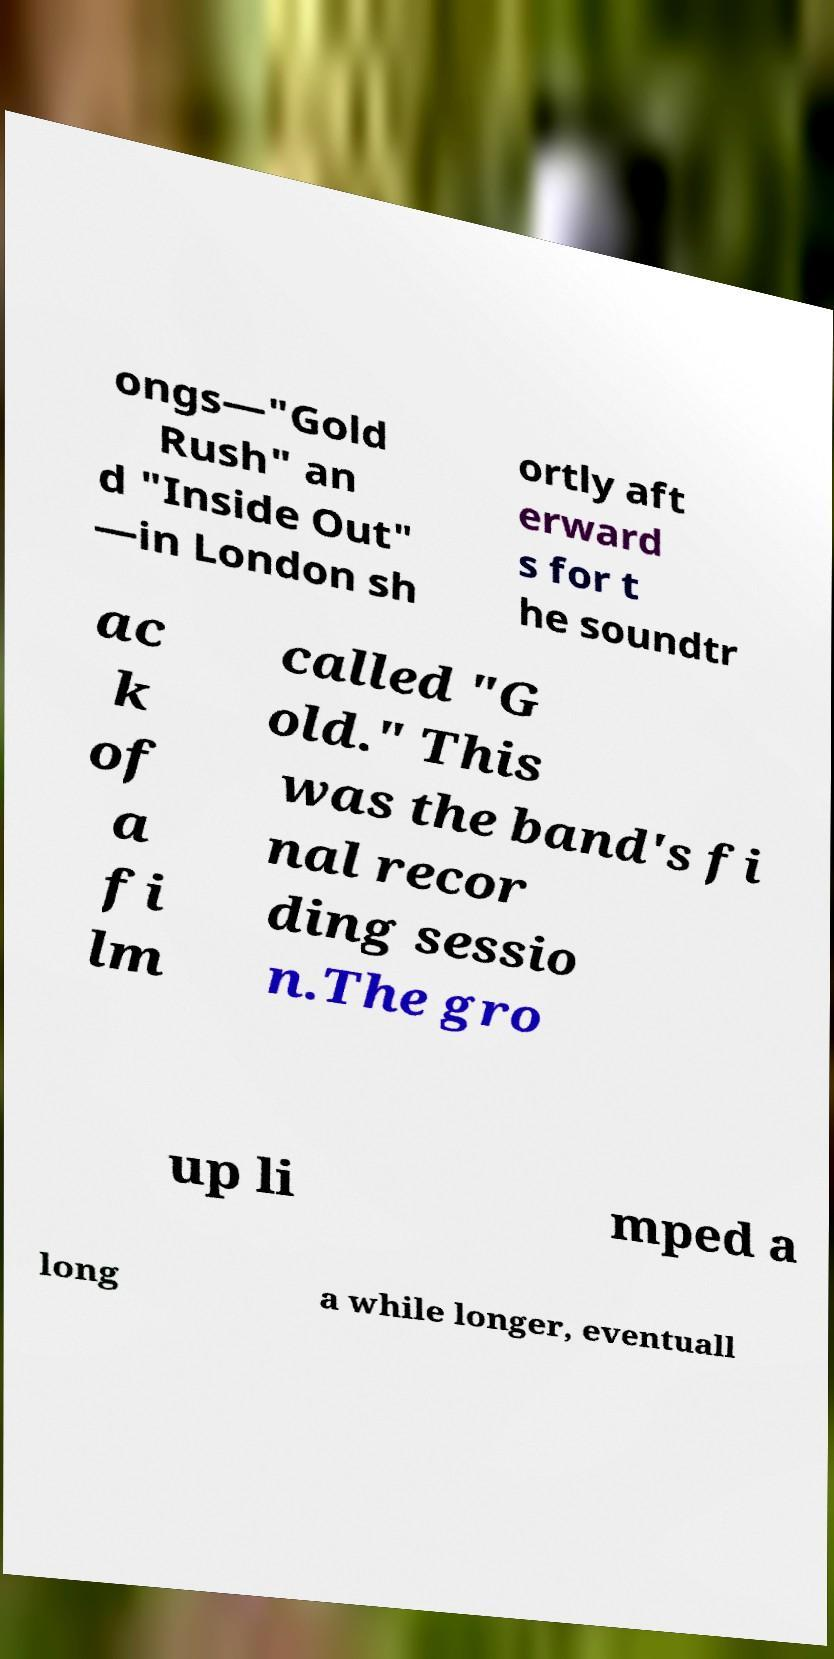Can you accurately transcribe the text from the provided image for me? ongs—"Gold Rush" an d "Inside Out" —in London sh ortly aft erward s for t he soundtr ac k of a fi lm called "G old." This was the band's fi nal recor ding sessio n.The gro up li mped a long a while longer, eventuall 